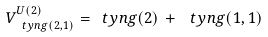Convert formula to latex. <formula><loc_0><loc_0><loc_500><loc_500>V _ { \ t y n g ( 2 , 1 ) } ^ { U ( 2 ) } = \ t y n g ( 2 ) \, + \, \ t y n g ( 1 , 1 )</formula> 